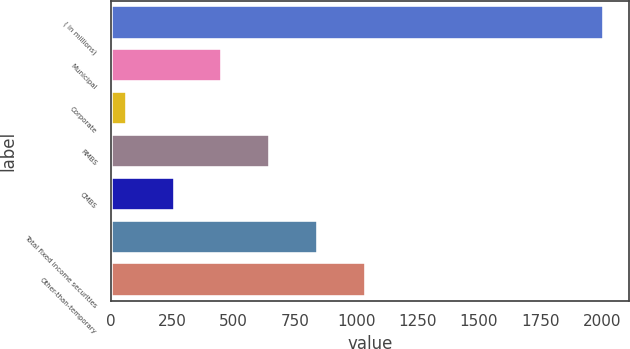Convert chart. <chart><loc_0><loc_0><loc_500><loc_500><bar_chart><fcel>( in millions)<fcel>Municipal<fcel>Corporate<fcel>RMBS<fcel>CMBS<fcel>Total fixed income securities<fcel>Other-than-temporary<nl><fcel>2010<fcel>454.8<fcel>66<fcel>649.2<fcel>260.4<fcel>843.6<fcel>1038<nl></chart> 